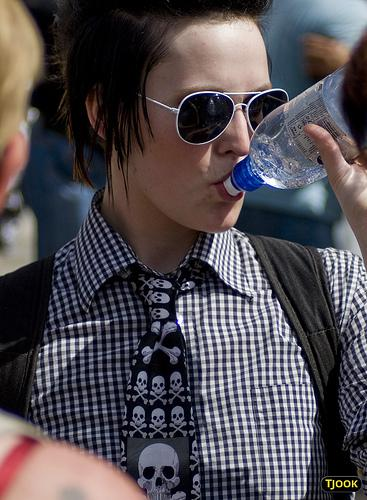Question: who is holding the bottle?
Choices:
A. The man.
B. The boy.
C. The girl.
D. The woman.
Answer with the letter. Answer: D Question: what color is the bottle?
Choices:
A. Red.
B. Brown.
C. Blue.
D. Yellow.
Answer with the letter. Answer: C 